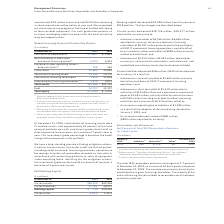According to International Business Machines's financial document, What was the decrease in Working capital from 2018? According to the financial document, $10,200 million. The relevant text states: "Working capital decreased $10,200 million from the year-end 2018 position. The key changes are described below:..." Also, What caused the current assets to decrease? A decline in receivables of $6,769 million ($6,695 million adjusted for currency) driven by a decline in financing receivables of $8,197 million primarily due to the wind down of OEM IT commercial financing operations; partially offset by an increase in other receivables of $989 million primarily related to divestitures; and • A decrease of $3,213 million ($3,052 million adjusted for currency) in cash and cash equivalents, restricted cash, and marketable securities primarily due to retirement of debt.. The document states: "• A decline in receivables of $6,769 million ($6,695 million adjusted for currency) driven by a decline in financing receivables of $8,197 million pri..." Also, What caused the current liabilities to decrease? • A decrease in accounts payable of $1,662 million primarily due to the wind down of OEM IT commercial financing operations; and • A decrease in short-term debt of $1,410 million due to maturities of $12,649 million and a decrease in commercial paper of $2,691 million; partially offset by reclassifications of $7,592 million from long-term debt to reflect upcoming maturities and issuances of $6,334 million; offset by • An increase in operating lease liabilities of $1,380 million as a result of the adoption of the new leasing standard on January 1, 2019; and • An increase in deferred income of $861 million ($890 million adjusted for currency).. The document states: "• A decrease in accounts payable of $1,662 million primarily due to the wind down of OEM IT commercial financing operations; and • A decrease in short..." Also, can you calculate: What was the increase / (decrease) in the current assets from 2018 to 2019? Based on the calculation: 38,420 - 49,146, the result is -10726 (in millions). This is based on the information: "Current assets $38,420 $49,146 Current assets $38,420 $49,146..." The key data points involved are: 38,420, 49,146. Also, can you calculate: What is the percentage increase / (decrease) in Current liabilities from 2018 to 2019? To answer this question, I need to perform calculations using the financial data. The calculation is: 37,701/38,227 - 1, which equals -1.38 (percentage). This is based on the information: "Current liabilities 37,701 38,227 Current liabilities 37,701 38,227..." The key data points involved are: 37,701, 38,227. Also, can you calculate: What is the average working capital? To answer this question, I need to perform calculations using the financial data. The calculation is: (718 + 10,918) / 2, which equals 5818 (in millions). This is based on the information: "Working capital $ 718 $10,918 Working capital $ 718 $10,918..." The key data points involved are: 10,918, 718. 